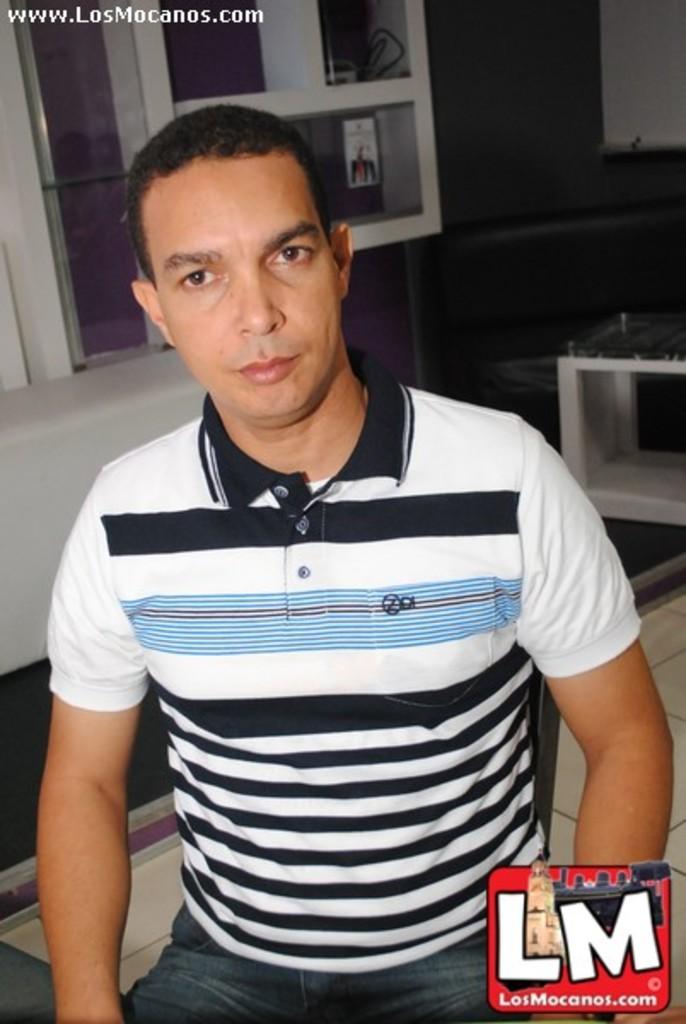What two letters appear in the photo?
Offer a terse response. Lm. What website hosts this photo?
Offer a very short reply. Www.losmocanos.com. 